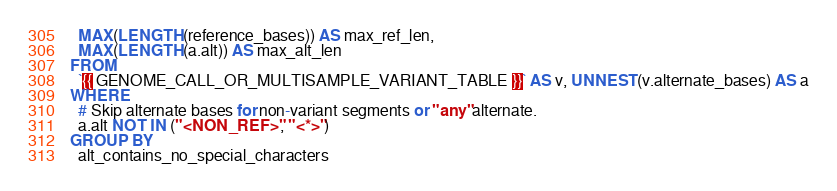<code> <loc_0><loc_0><loc_500><loc_500><_SQL_>  MAX(LENGTH(reference_bases)) AS max_ref_len,
  MAX(LENGTH(a.alt)) AS max_alt_len
FROM
  `{{ GENOME_CALL_OR_MULTISAMPLE_VARIANT_TABLE }}` AS v, UNNEST(v.alternate_bases) AS a
WHERE
  # Skip alternate bases for non-variant segments or "any" alternate.
  a.alt NOT IN ("<NON_REF>", "<*>")
GROUP BY
  alt_contains_no_special_characters
</code> 